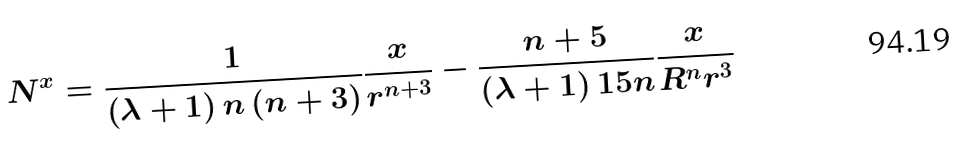<formula> <loc_0><loc_0><loc_500><loc_500>N ^ { x } = \frac { 1 } { \left ( \lambda + 1 \right ) n \left ( n + 3 \right ) } \frac { x } { r ^ { n + 3 } } - \frac { n + 5 } { \left ( \lambda + 1 \right ) 1 5 n } \frac { x } { R ^ { n } r ^ { 3 } }</formula> 